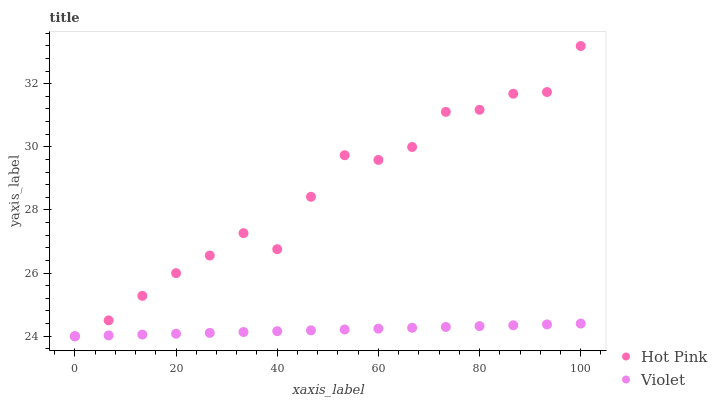Does Violet have the minimum area under the curve?
Answer yes or no. Yes. Does Hot Pink have the maximum area under the curve?
Answer yes or no. Yes. Does Violet have the maximum area under the curve?
Answer yes or no. No. Is Violet the smoothest?
Answer yes or no. Yes. Is Hot Pink the roughest?
Answer yes or no. Yes. Is Violet the roughest?
Answer yes or no. No. Does Hot Pink have the lowest value?
Answer yes or no. Yes. Does Hot Pink have the highest value?
Answer yes or no. Yes. Does Violet have the highest value?
Answer yes or no. No. Does Violet intersect Hot Pink?
Answer yes or no. Yes. Is Violet less than Hot Pink?
Answer yes or no. No. Is Violet greater than Hot Pink?
Answer yes or no. No. 